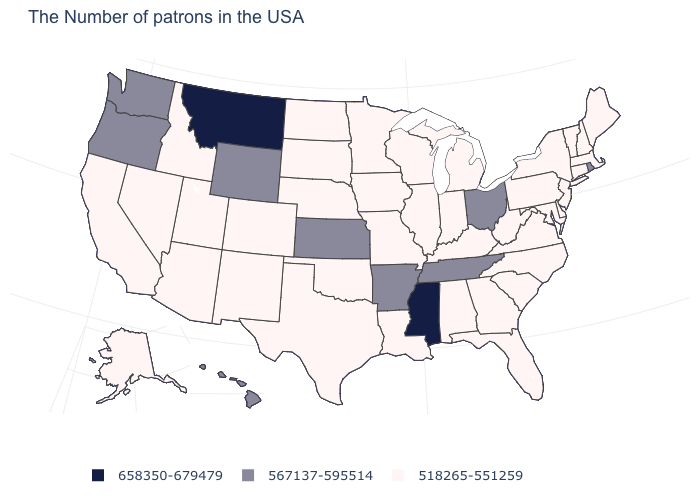Does Mississippi have the highest value in the USA?
Give a very brief answer. Yes. How many symbols are there in the legend?
Short answer required. 3. What is the value of Ohio?
Answer briefly. 567137-595514. Does Louisiana have the lowest value in the South?
Keep it brief. Yes. Which states hav the highest value in the West?
Write a very short answer. Montana. Does Wyoming have the same value as Massachusetts?
Answer briefly. No. What is the lowest value in states that border Arizona?
Short answer required. 518265-551259. Which states have the highest value in the USA?
Quick response, please. Mississippi, Montana. Does Arkansas have the lowest value in the USA?
Write a very short answer. No. Which states have the highest value in the USA?
Answer briefly. Mississippi, Montana. Name the states that have a value in the range 658350-679479?
Quick response, please. Mississippi, Montana. What is the lowest value in states that border Pennsylvania?
Be succinct. 518265-551259. Name the states that have a value in the range 518265-551259?
Give a very brief answer. Maine, Massachusetts, New Hampshire, Vermont, Connecticut, New York, New Jersey, Delaware, Maryland, Pennsylvania, Virginia, North Carolina, South Carolina, West Virginia, Florida, Georgia, Michigan, Kentucky, Indiana, Alabama, Wisconsin, Illinois, Louisiana, Missouri, Minnesota, Iowa, Nebraska, Oklahoma, Texas, South Dakota, North Dakota, Colorado, New Mexico, Utah, Arizona, Idaho, Nevada, California, Alaska. What is the value of Michigan?
Be succinct. 518265-551259. What is the value of Illinois?
Answer briefly. 518265-551259. 